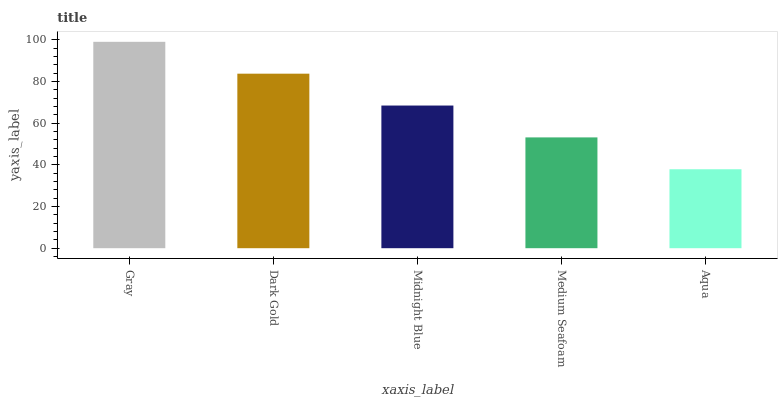Is Aqua the minimum?
Answer yes or no. Yes. Is Gray the maximum?
Answer yes or no. Yes. Is Dark Gold the minimum?
Answer yes or no. No. Is Dark Gold the maximum?
Answer yes or no. No. Is Gray greater than Dark Gold?
Answer yes or no. Yes. Is Dark Gold less than Gray?
Answer yes or no. Yes. Is Dark Gold greater than Gray?
Answer yes or no. No. Is Gray less than Dark Gold?
Answer yes or no. No. Is Midnight Blue the high median?
Answer yes or no. Yes. Is Midnight Blue the low median?
Answer yes or no. Yes. Is Aqua the high median?
Answer yes or no. No. Is Gray the low median?
Answer yes or no. No. 